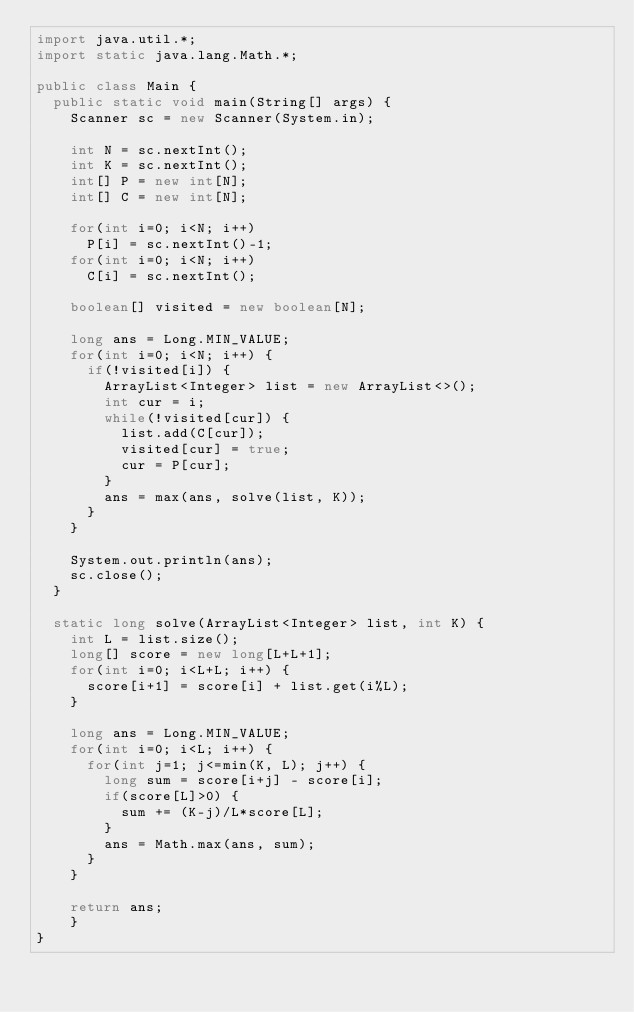<code> <loc_0><loc_0><loc_500><loc_500><_Java_>import java.util.*;
import static java.lang.Math.*;

public class Main {
	public static void main(String[] args) {
		Scanner sc = new Scanner(System.in);
		
		int N = sc.nextInt();
		int K = sc.nextInt();
		int[] P = new int[N];
		int[] C = new int[N];
		
		for(int i=0; i<N; i++)
			P[i] = sc.nextInt()-1;
		for(int i=0; i<N; i++)
			C[i] = sc.nextInt();
		
		boolean[] visited = new boolean[N];
		
		long ans = Long.MIN_VALUE;
		for(int i=0; i<N; i++) {
			if(!visited[i]) {
				ArrayList<Integer> list = new ArrayList<>();
				int cur = i;
				while(!visited[cur]) {
					list.add(C[cur]);
					visited[cur] = true;
					cur = P[cur];
				}
				ans = max(ans, solve(list, K));
			}
		}
		
		System.out.println(ans);
		sc.close();
	}
	
	static long solve(ArrayList<Integer> list, int K) {
		int L = list.size();
		long[] score = new long[L+L+1];
		for(int i=0; i<L+L; i++) {
			score[i+1] = score[i] + list.get(i%L);
		}
		
		long ans = Long.MIN_VALUE;
		for(int i=0; i<L; i++) {
			for(int j=1; j<=min(K, L); j++) {
				long sum = score[i+j] - score[i];
				if(score[L]>0) {
					sum += (K-j)/L*score[L];
				}
				ans = Math.max(ans, sum);
			}
		}
		
		return ans;
    }
}
</code> 